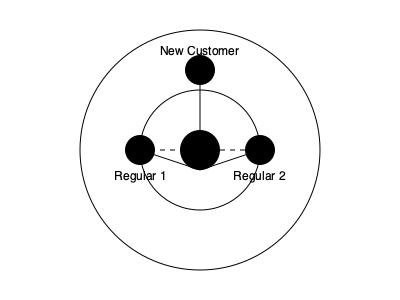In the given network graph representing social interactions in a coffee shop, what does the dashed line between Regular 1 and Regular 2 likely represent, and how might it affect the overall social dynamics? To analyze this network graph and understand its implications for social dynamics in a coffee shop, let's break it down step-by-step:

1. Node identification:
   - The central node represents the Barista
   - Three outer nodes represent Regular 1, Regular 2, and a New Customer

2. Connection types:
   - Solid lines connect the Barista to all other nodes
   - A dashed line connects Regular 1 and Regular 2

3. Interpretation of connections:
   - Solid lines likely represent direct, frequent interactions
   - The dashed line suggests a potential or indirect connection

4. Social dynamics analysis:
   - The Barista acts as a central hub, interacting with all customers
   - Regular customers have a strong connection to the Barista
   - The dashed line between Regular 1 and Regular 2 implies:
     a) They may know each other but don't interact as frequently as with the Barista
     b) They might have met through the coffee shop but aren't close friends
     c) There's potential for future direct interactions

5. Impact on overall dynamics:
   - The dashed line creates a "weak tie" in network theory
   - Weak ties can:
     a) Introduce new information or perspectives to the group
     b) Bridge different social circles
     c) Potentially evolve into stronger connections over time

6. Role of the New Customer:
   - Connected only to the Barista, representing an opportunity for integration
   - The existing network (including the weak tie) may influence how easily the New Customer assimilates

In conclusion, the dashed line represents a weak or potential connection between regular customers, which can enhance the coffee shop's social atmosphere by providing opportunities for new interactions and information exchange, ultimately contributing to a more dynamic and inclusive social environment.
Answer: Weak tie, enhancing social dynamics through potential interactions and information exchange 